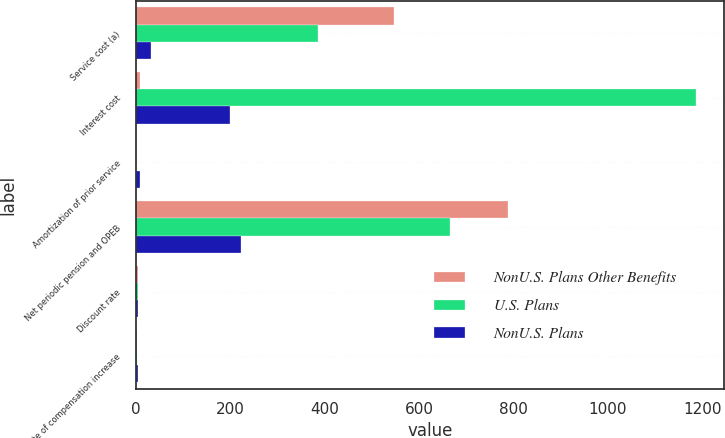<chart> <loc_0><loc_0><loc_500><loc_500><stacked_bar_chart><ecel><fcel>Service cost (a)<fcel>Interest cost<fcel>Amortization of prior service<fcel>Net periodic pension and OPEB<fcel>Discount rate<fcel>Rate of compensation increase<nl><fcel>NonU.S. Plans Other Benefits<fcel>548<fcel>9<fcel>1<fcel>789<fcel>4.96<fcel>3.96<nl><fcel>U.S. Plans<fcel>386<fcel>1187<fcel>1<fcel>666<fcel>5.09<fcel>3.25<nl><fcel>NonU.S. Plans<fcel>32<fcel>200<fcel>9<fcel>223<fcel>4.97<fcel>4.33<nl></chart> 